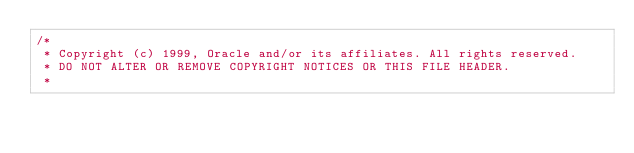Convert code to text. <code><loc_0><loc_0><loc_500><loc_500><_Java_>/*
 * Copyright (c) 1999, Oracle and/or its affiliates. All rights reserved.
 * DO NOT ALTER OR REMOVE COPYRIGHT NOTICES OR THIS FILE HEADER.
 *</code> 